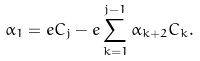Convert formula to latex. <formula><loc_0><loc_0><loc_500><loc_500>\alpha _ { 1 } = e C _ { j } - e \sum _ { k = 1 } ^ { j - 1 } \alpha _ { k + 2 } C _ { k } .</formula> 